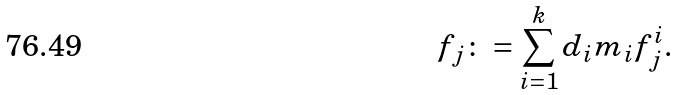<formula> <loc_0><loc_0><loc_500><loc_500>f _ { j } \colon = \sum _ { i = 1 } ^ { k } d _ { i } m _ { i } f ^ { i } _ { j } .</formula> 